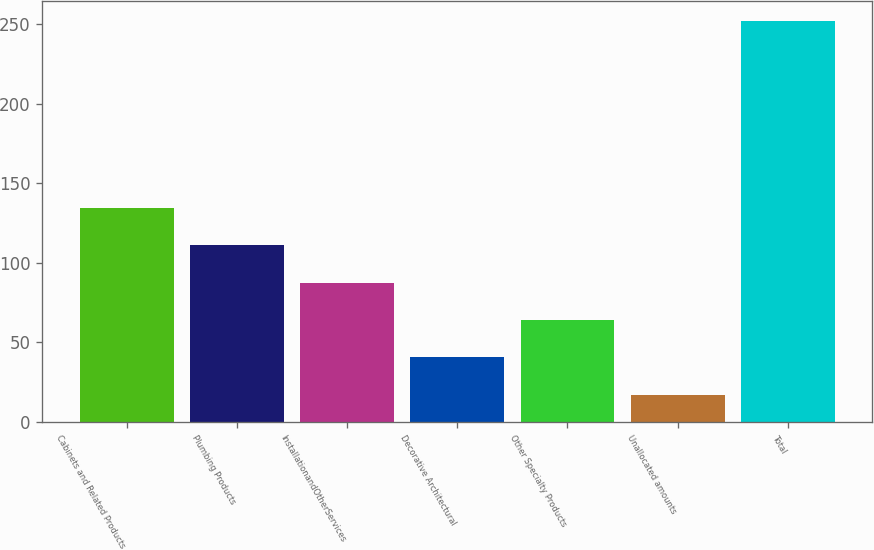Convert chart. <chart><loc_0><loc_0><loc_500><loc_500><bar_chart><fcel>Cabinets and Related Products<fcel>Plumbing Products<fcel>InstallationandOtherServices<fcel>Decorative Architectural<fcel>Other Specialty Products<fcel>Unallocated amounts<fcel>Total<nl><fcel>134.5<fcel>111<fcel>87.5<fcel>40.5<fcel>64<fcel>17<fcel>252<nl></chart> 